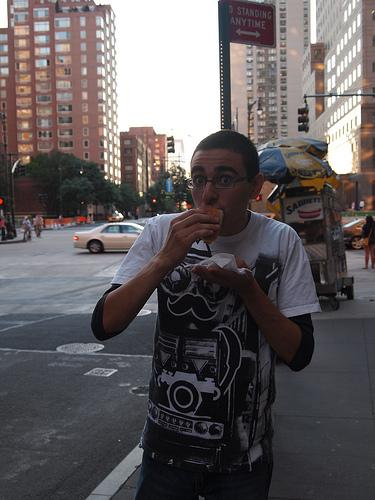Describe the main buildings present in the image. Tall red brick buildings on the side of the road. Mention an interesting aspect of the main subject's attire. The man is wearing a black and white t-shirt with a black mustache graphic. List the colors and location of the umbrella in the image. Yellow and blue-colored umbrella on a hot dog stand. Identify the main activity depicted in the image. A man enjoying his hot dog on the street. What is the man with glasses doing in the image? He is eating a hot dog while walking on the street. What is the most noticeable transportation mode in the image? A tan car driving on the road. Mention an object that the main subject in the image is holding. The man is holding a partially eaten hotdog. Name at least two accessories worn by the main subject in the image. Glasses on the man's face and a black mustache on his shirt. Provide a brief description of the sign on the pole. The sign is red and says "No standing anytime." What can be seen on the sidewalk in the image? A hot dog stand with yellow and blue umbrellas and a man eating a hot dog. 